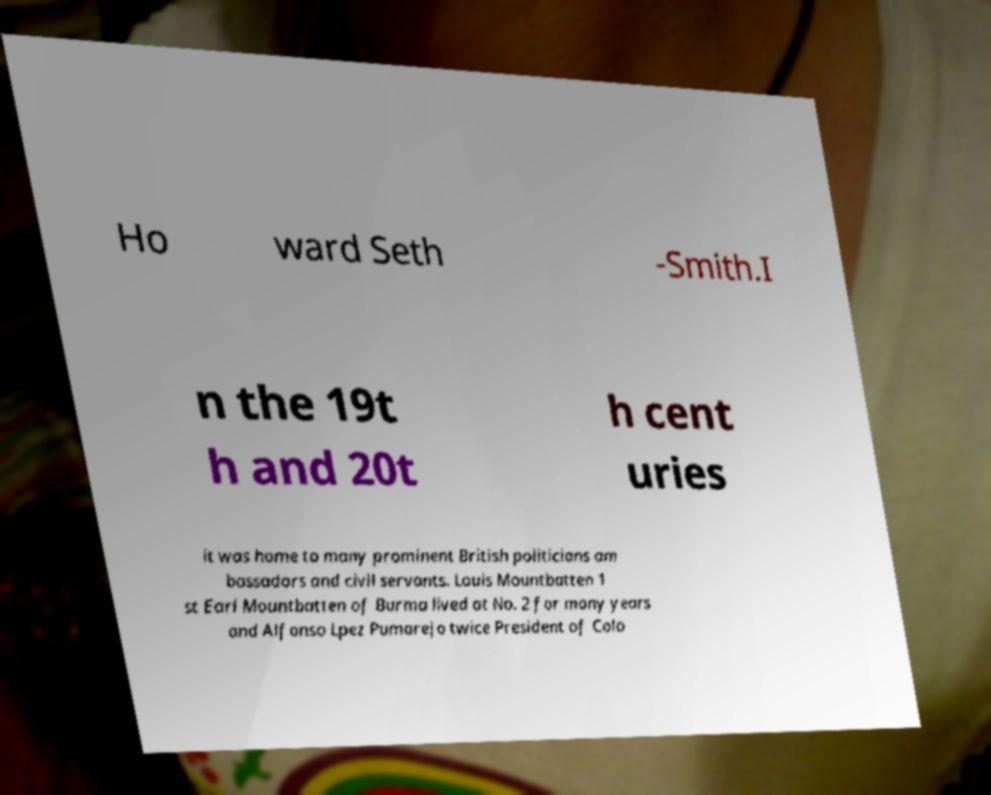Please identify and transcribe the text found in this image. Ho ward Seth -Smith.I n the 19t h and 20t h cent uries it was home to many prominent British politicians am bassadors and civil servants. Louis Mountbatten 1 st Earl Mountbatten of Burma lived at No. 2 for many years and Alfonso Lpez Pumarejo twice President of Colo 